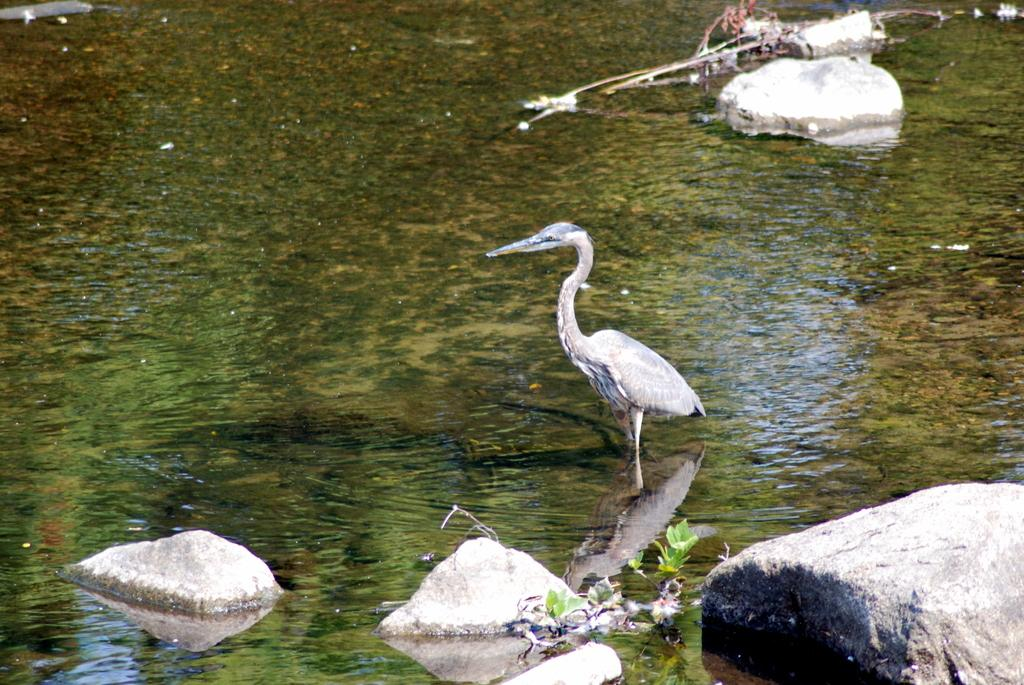What is the primary element in the image? There is water in the image. What type of animal can be seen in the image? There is a bird in the image. What other living organisms are present in the image? There are plants in the image. What is the terrain like in the image? There are rocks in the water in the image. Can you describe the object towards the top of the image? There is an object towards the top of the image, but its description is not provided in the facts. What type of pancake is floating on the water in the image? There is no pancake present in the image; it features water, a bird, plants, rocks, and an unspecified object. 